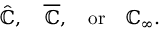Convert formula to latex. <formula><loc_0><loc_0><loc_500><loc_500>{ \hat { \mathbb { C } } } , \quad \overline { { \mathbb { C } } } , \quad o r \quad \mathbb { C } _ { \infty } .</formula> 